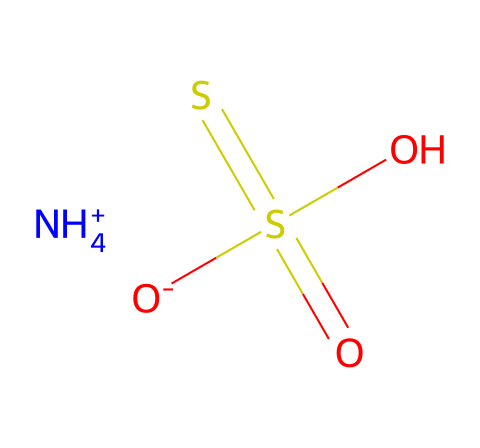how many sulfur atoms are present in the structure? The structure shows one sulfur atom in the thiosulfate group and another in the sulfate group. Hence, the total is two sulfur atoms.
Answer: two what is the oxidation state of the sulfur in ammonium thiosulfate? In ammonium thiosulfate, one sulfur atom (in the sulfate) is in the +6 oxidation state, and the other sulfur (in thiosulfate) is in the +2 oxidation state. Therefore, there are two distinct oxidation states.
Answer: +6 and +2 what type of chemical bonding is present between the nitrogen and hydrogen in the ammonium ion? The bond between nitrogen and hydrogen in the ammonium ion is a covalent bond, as nitrogen shares its electrons with the hydrogen atoms.
Answer: covalent how many oxygen atoms are present in the chemical structure? The chemical structure includes a total of four oxygen atoms: two in sulfate and two in thiosulfate.
Answer: four which component of the chemical structure contributes to its stabilizing effect in imaging data processing? The thiosulfate group (S2O3) contributes due to its ability to reduce silver ions, stabilizing imaging.
Answer: thiosulfate how does the presence of the ammonium ion affect the solubility of ammonium thiosulfate in water? The ammonium ion (NH4+) is highly soluble in water due to strong ionic interactions with water molecules, enhancing the overall solubility of the compound.
Answer: increases solubility 